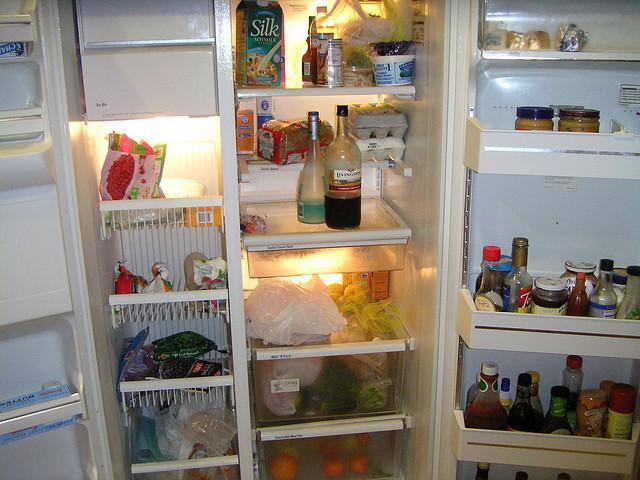How many bottles are in the picture?
Give a very brief answer. 2. How many toilet bowl brushes are in this picture?
Give a very brief answer. 0. 